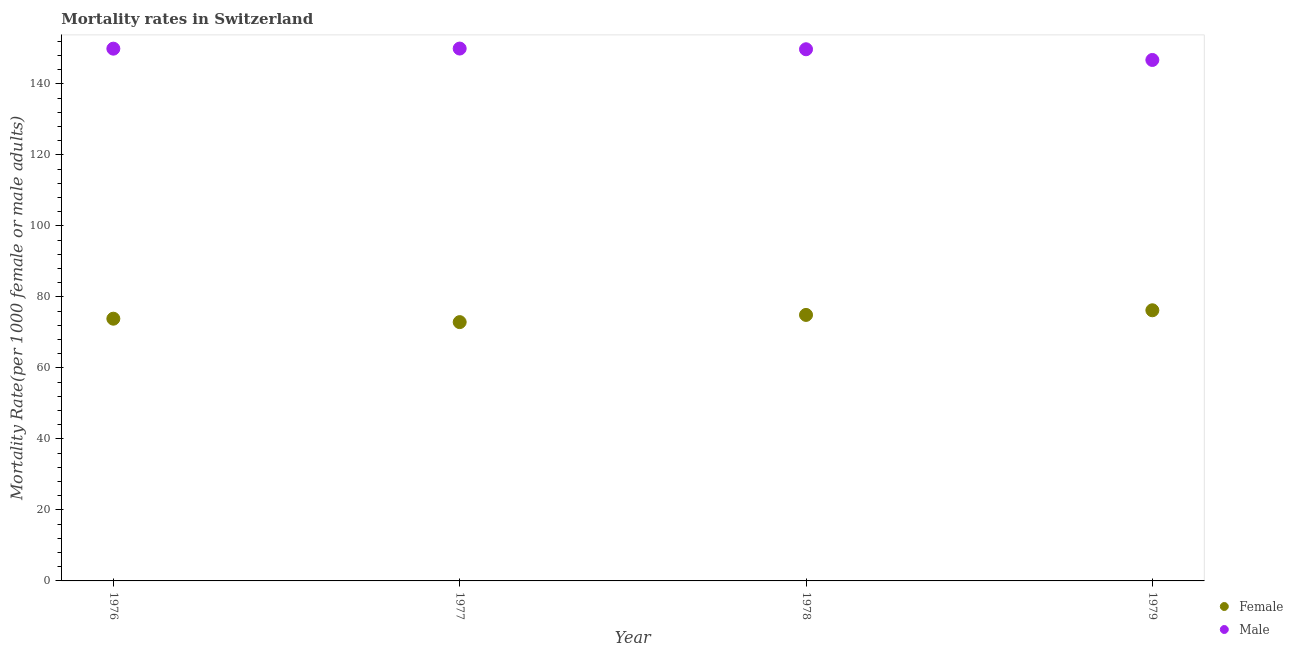What is the male mortality rate in 1977?
Your answer should be very brief. 149.94. Across all years, what is the maximum male mortality rate?
Keep it short and to the point. 149.94. Across all years, what is the minimum male mortality rate?
Make the answer very short. 146.73. In which year was the female mortality rate maximum?
Provide a succinct answer. 1979. In which year was the female mortality rate minimum?
Provide a succinct answer. 1977. What is the total female mortality rate in the graph?
Your answer should be compact. 297.9. What is the difference between the female mortality rate in 1976 and that in 1978?
Keep it short and to the point. -1.07. What is the difference between the male mortality rate in 1979 and the female mortality rate in 1978?
Your answer should be very brief. 71.81. What is the average male mortality rate per year?
Provide a succinct answer. 149.08. In the year 1979, what is the difference between the male mortality rate and female mortality rate?
Your answer should be very brief. 70.5. In how many years, is the male mortality rate greater than 52?
Keep it short and to the point. 4. What is the ratio of the male mortality rate in 1976 to that in 1978?
Offer a terse response. 1. What is the difference between the highest and the second highest male mortality rate?
Provide a short and direct response. 0.03. What is the difference between the highest and the lowest female mortality rate?
Your response must be concise. 3.33. In how many years, is the male mortality rate greater than the average male mortality rate taken over all years?
Provide a succinct answer. 3. Does the female mortality rate monotonically increase over the years?
Provide a succinct answer. No. Is the female mortality rate strictly greater than the male mortality rate over the years?
Keep it short and to the point. No. Is the female mortality rate strictly less than the male mortality rate over the years?
Make the answer very short. Yes. How many years are there in the graph?
Your answer should be compact. 4. What is the difference between two consecutive major ticks on the Y-axis?
Offer a terse response. 20. How many legend labels are there?
Your answer should be very brief. 2. What is the title of the graph?
Ensure brevity in your answer.  Mortality rates in Switzerland. What is the label or title of the X-axis?
Provide a short and direct response. Year. What is the label or title of the Y-axis?
Your answer should be very brief. Mortality Rate(per 1000 female or male adults). What is the Mortality Rate(per 1000 female or male adults) in Female in 1976?
Your response must be concise. 73.86. What is the Mortality Rate(per 1000 female or male adults) of Male in 1976?
Offer a very short reply. 149.91. What is the Mortality Rate(per 1000 female or male adults) of Female in 1977?
Keep it short and to the point. 72.89. What is the Mortality Rate(per 1000 female or male adults) in Male in 1977?
Your answer should be very brief. 149.94. What is the Mortality Rate(per 1000 female or male adults) of Female in 1978?
Provide a succinct answer. 74.92. What is the Mortality Rate(per 1000 female or male adults) in Male in 1978?
Give a very brief answer. 149.74. What is the Mortality Rate(per 1000 female or male adults) in Female in 1979?
Your response must be concise. 76.23. What is the Mortality Rate(per 1000 female or male adults) of Male in 1979?
Offer a terse response. 146.73. Across all years, what is the maximum Mortality Rate(per 1000 female or male adults) of Female?
Offer a terse response. 76.23. Across all years, what is the maximum Mortality Rate(per 1000 female or male adults) in Male?
Make the answer very short. 149.94. Across all years, what is the minimum Mortality Rate(per 1000 female or male adults) of Female?
Give a very brief answer. 72.89. Across all years, what is the minimum Mortality Rate(per 1000 female or male adults) in Male?
Offer a terse response. 146.73. What is the total Mortality Rate(per 1000 female or male adults) in Female in the graph?
Keep it short and to the point. 297.9. What is the total Mortality Rate(per 1000 female or male adults) in Male in the graph?
Offer a very short reply. 596.33. What is the difference between the Mortality Rate(per 1000 female or male adults) of Male in 1976 and that in 1977?
Give a very brief answer. -0.03. What is the difference between the Mortality Rate(per 1000 female or male adults) of Female in 1976 and that in 1978?
Your answer should be very brief. -1.07. What is the difference between the Mortality Rate(per 1000 female or male adults) of Male in 1976 and that in 1978?
Your answer should be very brief. 0.17. What is the difference between the Mortality Rate(per 1000 female or male adults) in Female in 1976 and that in 1979?
Ensure brevity in your answer.  -2.37. What is the difference between the Mortality Rate(per 1000 female or male adults) of Male in 1976 and that in 1979?
Offer a very short reply. 3.18. What is the difference between the Mortality Rate(per 1000 female or male adults) in Female in 1977 and that in 1978?
Give a very brief answer. -2.03. What is the difference between the Mortality Rate(per 1000 female or male adults) in Male in 1977 and that in 1978?
Make the answer very short. 0.2. What is the difference between the Mortality Rate(per 1000 female or male adults) in Female in 1977 and that in 1979?
Provide a short and direct response. -3.33. What is the difference between the Mortality Rate(per 1000 female or male adults) of Male in 1977 and that in 1979?
Offer a very short reply. 3.21. What is the difference between the Mortality Rate(per 1000 female or male adults) in Female in 1978 and that in 1979?
Your answer should be very brief. -1.3. What is the difference between the Mortality Rate(per 1000 female or male adults) in Male in 1978 and that in 1979?
Offer a terse response. 3.01. What is the difference between the Mortality Rate(per 1000 female or male adults) in Female in 1976 and the Mortality Rate(per 1000 female or male adults) in Male in 1977?
Offer a very short reply. -76.09. What is the difference between the Mortality Rate(per 1000 female or male adults) in Female in 1976 and the Mortality Rate(per 1000 female or male adults) in Male in 1978?
Provide a succinct answer. -75.89. What is the difference between the Mortality Rate(per 1000 female or male adults) in Female in 1976 and the Mortality Rate(per 1000 female or male adults) in Male in 1979?
Ensure brevity in your answer.  -72.87. What is the difference between the Mortality Rate(per 1000 female or male adults) of Female in 1977 and the Mortality Rate(per 1000 female or male adults) of Male in 1978?
Offer a very short reply. -76.85. What is the difference between the Mortality Rate(per 1000 female or male adults) in Female in 1977 and the Mortality Rate(per 1000 female or male adults) in Male in 1979?
Keep it short and to the point. -73.84. What is the difference between the Mortality Rate(per 1000 female or male adults) of Female in 1978 and the Mortality Rate(per 1000 female or male adults) of Male in 1979?
Make the answer very short. -71.81. What is the average Mortality Rate(per 1000 female or male adults) of Female per year?
Offer a terse response. 74.47. What is the average Mortality Rate(per 1000 female or male adults) of Male per year?
Provide a succinct answer. 149.08. In the year 1976, what is the difference between the Mortality Rate(per 1000 female or male adults) in Female and Mortality Rate(per 1000 female or male adults) in Male?
Keep it short and to the point. -76.06. In the year 1977, what is the difference between the Mortality Rate(per 1000 female or male adults) in Female and Mortality Rate(per 1000 female or male adults) in Male?
Offer a terse response. -77.05. In the year 1978, what is the difference between the Mortality Rate(per 1000 female or male adults) in Female and Mortality Rate(per 1000 female or male adults) in Male?
Make the answer very short. -74.82. In the year 1979, what is the difference between the Mortality Rate(per 1000 female or male adults) of Female and Mortality Rate(per 1000 female or male adults) of Male?
Keep it short and to the point. -70.5. What is the ratio of the Mortality Rate(per 1000 female or male adults) in Female in 1976 to that in 1977?
Your answer should be very brief. 1.01. What is the ratio of the Mortality Rate(per 1000 female or male adults) of Male in 1976 to that in 1977?
Make the answer very short. 1. What is the ratio of the Mortality Rate(per 1000 female or male adults) of Female in 1976 to that in 1978?
Make the answer very short. 0.99. What is the ratio of the Mortality Rate(per 1000 female or male adults) of Male in 1976 to that in 1978?
Keep it short and to the point. 1. What is the ratio of the Mortality Rate(per 1000 female or male adults) of Female in 1976 to that in 1979?
Your answer should be very brief. 0.97. What is the ratio of the Mortality Rate(per 1000 female or male adults) of Male in 1976 to that in 1979?
Offer a terse response. 1.02. What is the ratio of the Mortality Rate(per 1000 female or male adults) in Female in 1977 to that in 1978?
Your answer should be compact. 0.97. What is the ratio of the Mortality Rate(per 1000 female or male adults) in Male in 1977 to that in 1978?
Ensure brevity in your answer.  1. What is the ratio of the Mortality Rate(per 1000 female or male adults) in Female in 1977 to that in 1979?
Provide a short and direct response. 0.96. What is the ratio of the Mortality Rate(per 1000 female or male adults) in Male in 1977 to that in 1979?
Offer a very short reply. 1.02. What is the ratio of the Mortality Rate(per 1000 female or male adults) of Female in 1978 to that in 1979?
Provide a succinct answer. 0.98. What is the ratio of the Mortality Rate(per 1000 female or male adults) in Male in 1978 to that in 1979?
Keep it short and to the point. 1.02. What is the difference between the highest and the second highest Mortality Rate(per 1000 female or male adults) in Female?
Offer a terse response. 1.3. What is the difference between the highest and the second highest Mortality Rate(per 1000 female or male adults) of Male?
Your answer should be compact. 0.03. What is the difference between the highest and the lowest Mortality Rate(per 1000 female or male adults) of Female?
Your response must be concise. 3.33. What is the difference between the highest and the lowest Mortality Rate(per 1000 female or male adults) in Male?
Give a very brief answer. 3.21. 